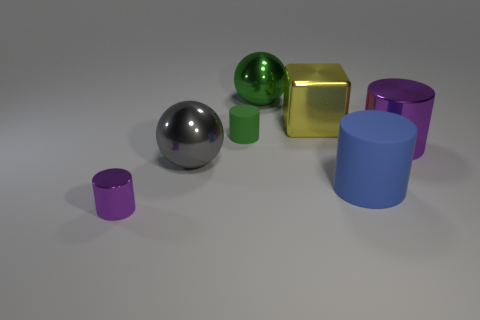Is the yellow thing the same shape as the large purple metallic thing? No, they are not the same shape. The yellow object is a cube, characterized by its six square faces and edges of equal length, while the large purple object is a cylinder, distinguished by its circular base and elongated, curved surface. 